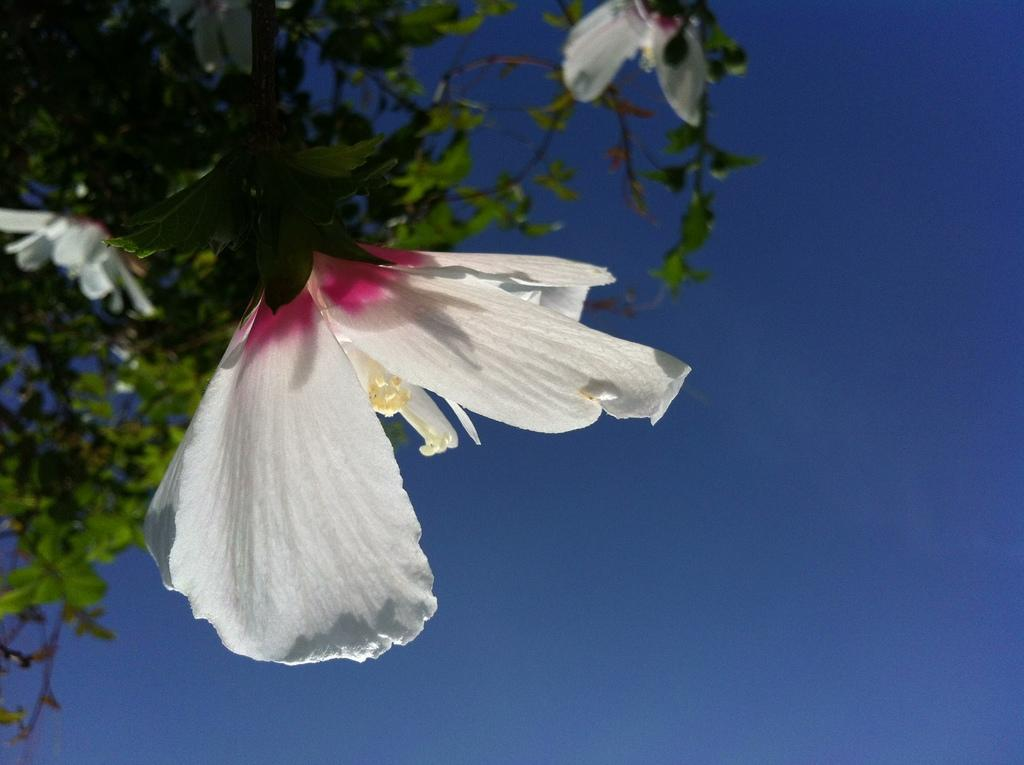What type of plant can be seen in the image? There is a tree with flowers in the image. What can be seen in the background of the image? The sky is visible in the background of the image. What position does the arm of the tree hold in the image? There is no mention of an arm in the image, as it features a tree with flowers and a visible sky in the background. 